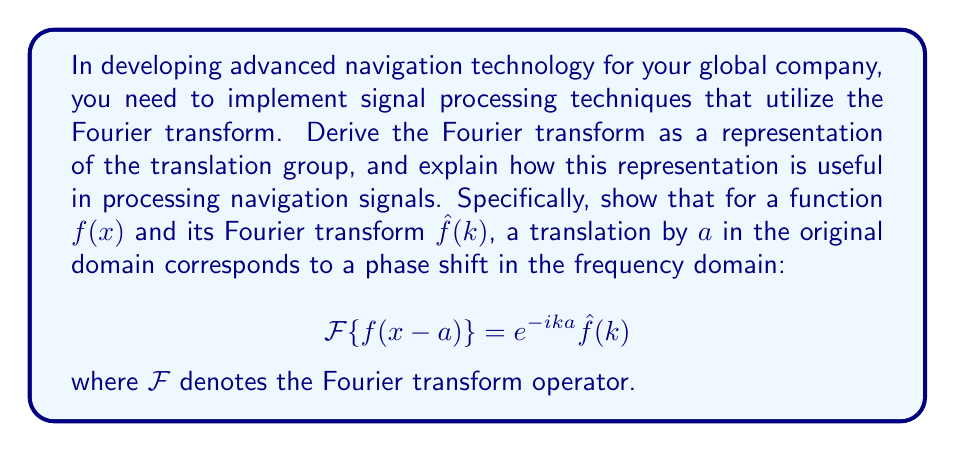Give your solution to this math problem. Let's derive this result step by step:

1) First, recall the definition of the Fourier transform:

   $$\hat{f}(k) = \mathcal{F}\{f(x)\} = \int_{-\infty}^{\infty} f(x) e^{-ikx} dx$$

2) Now, consider a translated function $g(x) = f(x-a)$. We want to find its Fourier transform:

   $$\mathcal{F}\{g(x)\} = \mathcal{F}\{f(x-a)\} = \int_{-\infty}^{\infty} f(x-a) e^{-ikx} dx$$

3) Make a change of variables: let $u = x-a$, so $x = u+a$ and $dx = du$:

   $$\mathcal{F}\{f(x-a)\} = \int_{-\infty}^{\infty} f(u) e^{-ik(u+a)} du$$

4) Factor out the constant term from the exponential:

   $$\mathcal{F}\{f(x-a)\} = e^{-ika} \int_{-\infty}^{\infty} f(u) e^{-iku} du$$

5) The integral is now just the Fourier transform of $f(u)$:

   $$\mathcal{F}\{f(x-a)\} = e^{-ika} \hat{f}(k)$$

This result shows that translation in the spatial domain corresponds to a phase shift in the frequency domain. In the context of navigation technology, this property is extremely useful:

1) Signal delays: In GPS and other navigation systems, signal delays correspond to translations in the time domain. The Fourier transform allows us to easily account for these delays in the frequency domain.

2) Doppler effect: The Doppler shift, crucial in determining relative velocities, can be interpreted as a frequency translation. The Fourier transform's properties make it easier to analyze and correct for Doppler effects.

3) Efficient processing: Many signal processing operations become simpler multiplications in the frequency domain, allowing for more efficient computations in navigation algorithms.

4) Filtering: The convolution theorem states that convolution in the time domain is equivalent to multiplication in the frequency domain. This property, combined with the translation property, allows for efficient implementation of various filters used in signal processing for navigation.

By understanding and utilizing this property of the Fourier transform, you can develop more efficient and accurate navigation algorithms for your global navigation technology company.
Answer: $\mathcal{F}\{f(x-a)\} = e^{-ika}\hat{f}(k)$ 